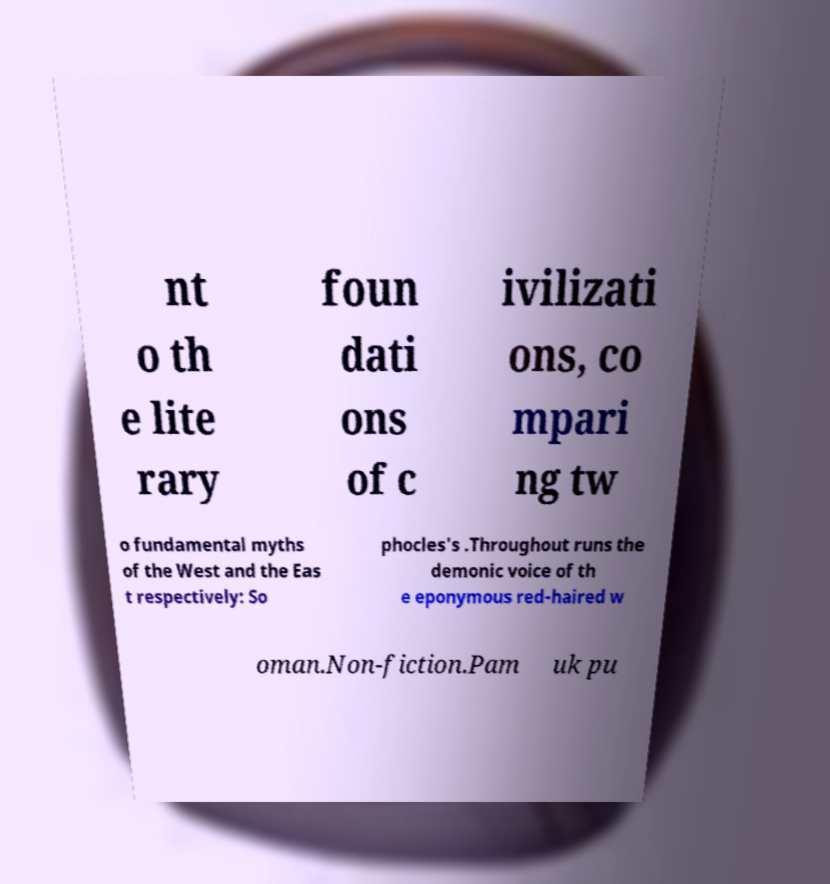Can you accurately transcribe the text from the provided image for me? nt o th e lite rary foun dati ons of c ivilizati ons, co mpari ng tw o fundamental myths of the West and the Eas t respectively: So phocles's .Throughout runs the demonic voice of th e eponymous red-haired w oman.Non-fiction.Pam uk pu 